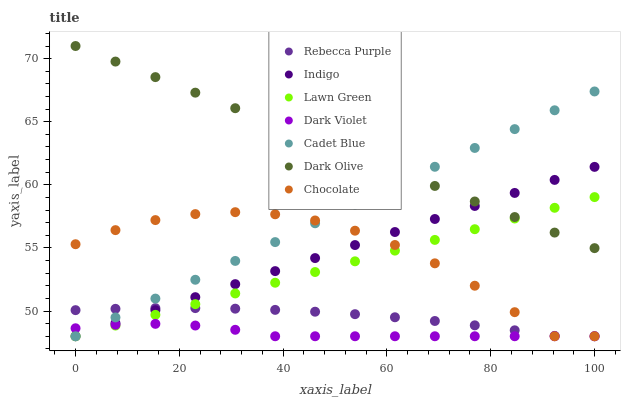Does Dark Violet have the minimum area under the curve?
Answer yes or no. Yes. Does Dark Olive have the maximum area under the curve?
Answer yes or no. Yes. Does Cadet Blue have the minimum area under the curve?
Answer yes or no. No. Does Cadet Blue have the maximum area under the curve?
Answer yes or no. No. Is Indigo the smoothest?
Answer yes or no. Yes. Is Chocolate the roughest?
Answer yes or no. Yes. Is Cadet Blue the smoothest?
Answer yes or no. No. Is Cadet Blue the roughest?
Answer yes or no. No. Does Lawn Green have the lowest value?
Answer yes or no. Yes. Does Dark Olive have the lowest value?
Answer yes or no. No. Does Dark Olive have the highest value?
Answer yes or no. Yes. Does Cadet Blue have the highest value?
Answer yes or no. No. Is Dark Violet less than Dark Olive?
Answer yes or no. Yes. Is Dark Olive greater than Rebecca Purple?
Answer yes or no. Yes. Does Lawn Green intersect Indigo?
Answer yes or no. Yes. Is Lawn Green less than Indigo?
Answer yes or no. No. Is Lawn Green greater than Indigo?
Answer yes or no. No. Does Dark Violet intersect Dark Olive?
Answer yes or no. No. 